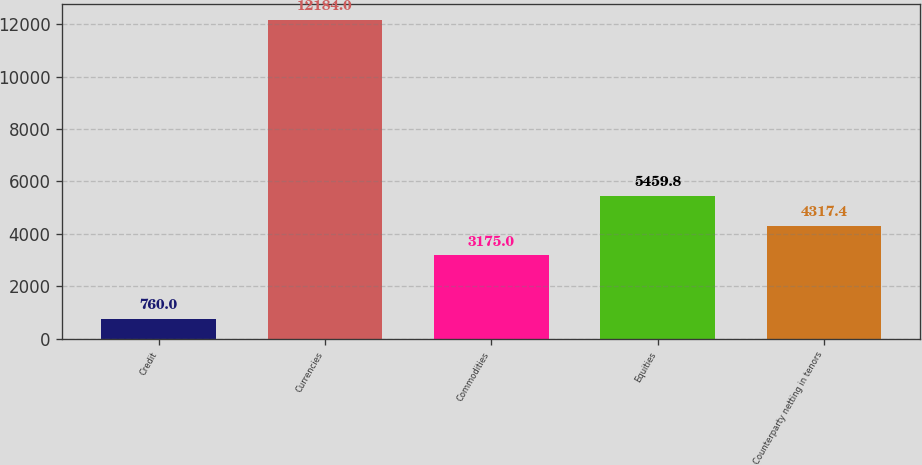<chart> <loc_0><loc_0><loc_500><loc_500><bar_chart><fcel>Credit<fcel>Currencies<fcel>Commodities<fcel>Equities<fcel>Counterparty netting in tenors<nl><fcel>760<fcel>12184<fcel>3175<fcel>5459.8<fcel>4317.4<nl></chart> 